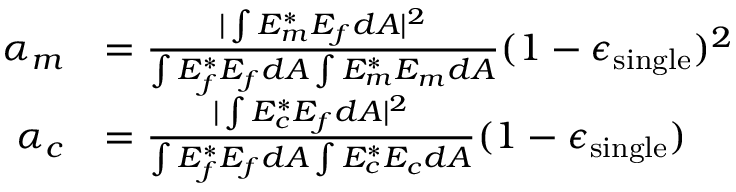Convert formula to latex. <formula><loc_0><loc_0><loc_500><loc_500>\begin{array} { r l } { \alpha _ { m } } & { = \frac { | \int E _ { m } ^ { * } E _ { f } d A | ^ { 2 } } { \int E _ { f } ^ { * } E _ { f } d A \int E _ { m } ^ { * } E _ { m } d A } ( 1 - \epsilon _ { \sin g l e } ) ^ { 2 } } \\ { \alpha _ { c } } & { = \frac { | \int E _ { c } ^ { * } E _ { f } d A | ^ { 2 } } { \int E _ { f } ^ { * } E _ { f } d A \int E _ { c } ^ { * } E _ { c } d A } ( 1 - \epsilon _ { \sin g l e } ) } \end{array}</formula> 